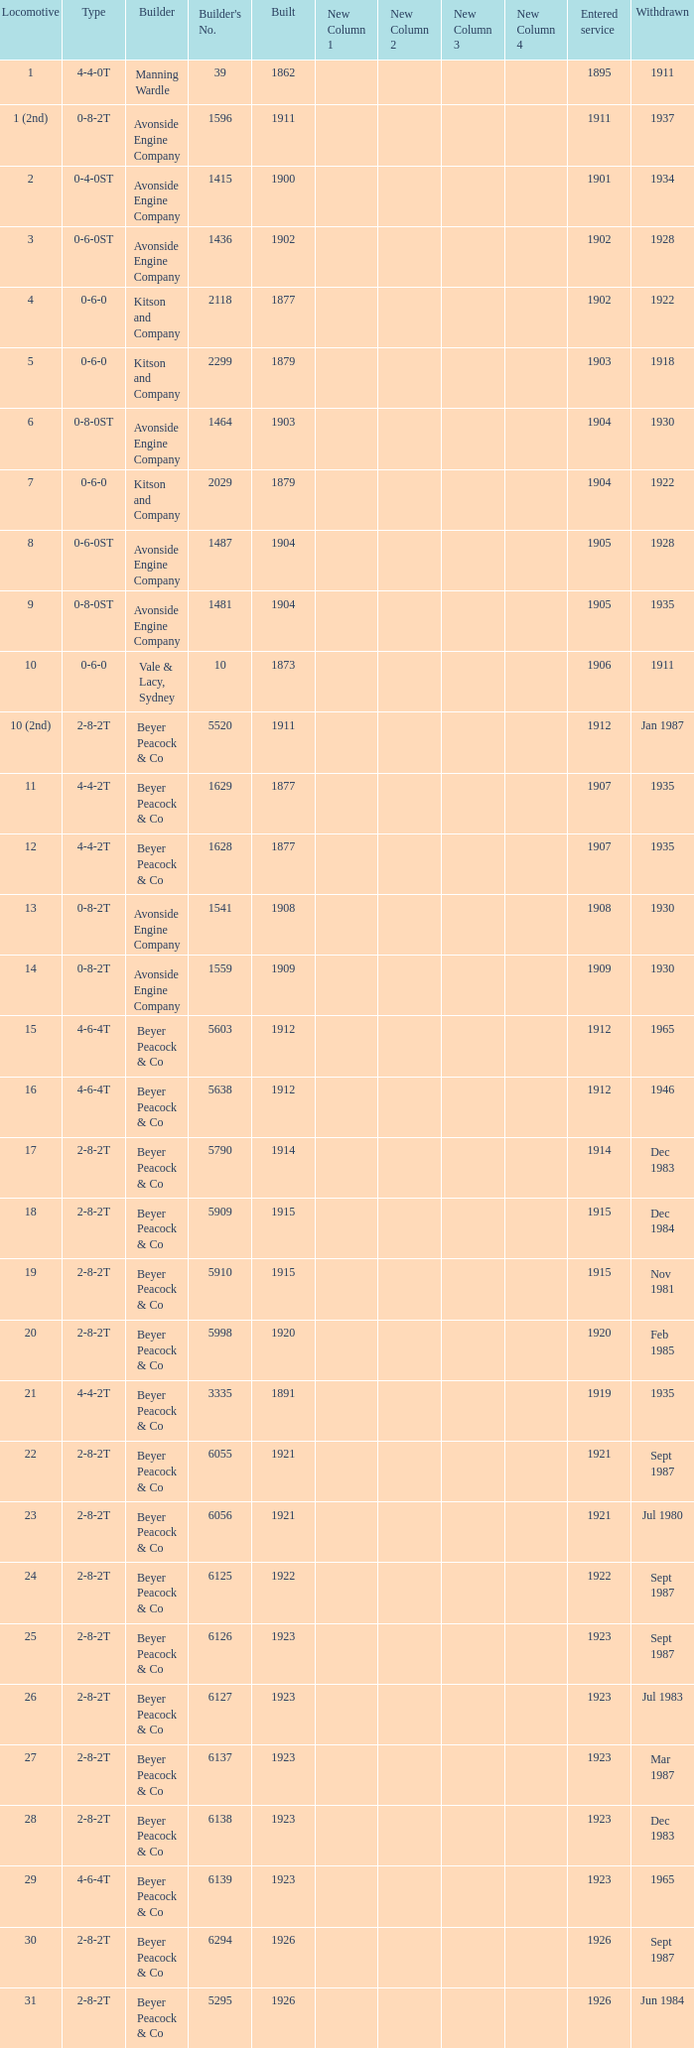Which locomotive had a 2-8-2t type, entered service year prior to 1915, and which was built after 1911? 17.0. 